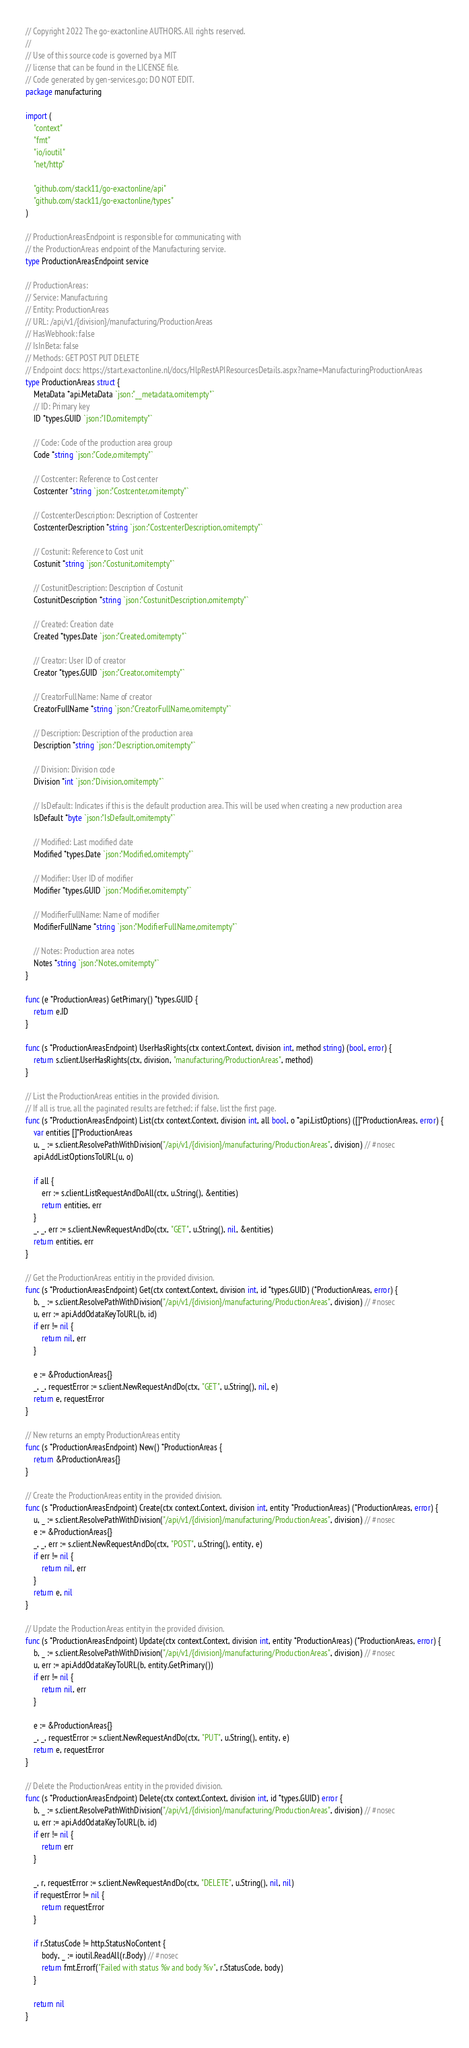<code> <loc_0><loc_0><loc_500><loc_500><_Go_>// Copyright 2022 The go-exactonline AUTHORS. All rights reserved.
//
// Use of this source code is governed by a MIT
// license that can be found in the LICENSE file.
// Code generated by gen-services.go; DO NOT EDIT.
package manufacturing

import (
	"context"
	"fmt"
	"io/ioutil"
	"net/http"

	"github.com/stack11/go-exactonline/api"
	"github.com/stack11/go-exactonline/types"
)

// ProductionAreasEndpoint is responsible for communicating with
// the ProductionAreas endpoint of the Manufacturing service.
type ProductionAreasEndpoint service

// ProductionAreas:
// Service: Manufacturing
// Entity: ProductionAreas
// URL: /api/v1/{division}/manufacturing/ProductionAreas
// HasWebhook: false
// IsInBeta: false
// Methods: GET POST PUT DELETE
// Endpoint docs: https://start.exactonline.nl/docs/HlpRestAPIResourcesDetails.aspx?name=ManufacturingProductionAreas
type ProductionAreas struct {
	MetaData *api.MetaData `json:"__metadata,omitempty"`
	// ID: Primary key
	ID *types.GUID `json:"ID,omitempty"`

	// Code: Code of the production area group
	Code *string `json:"Code,omitempty"`

	// Costcenter: Reference to Cost center
	Costcenter *string `json:"Costcenter,omitempty"`

	// CostcenterDescription: Description of Costcenter
	CostcenterDescription *string `json:"CostcenterDescription,omitempty"`

	// Costunit: Reference to Cost unit
	Costunit *string `json:"Costunit,omitempty"`

	// CostunitDescription: Description of Costunit
	CostunitDescription *string `json:"CostunitDescription,omitempty"`

	// Created: Creation date
	Created *types.Date `json:"Created,omitempty"`

	// Creator: User ID of creator
	Creator *types.GUID `json:"Creator,omitempty"`

	// CreatorFullName: Name of creator
	CreatorFullName *string `json:"CreatorFullName,omitempty"`

	// Description: Description of the production area
	Description *string `json:"Description,omitempty"`

	// Division: Division code
	Division *int `json:"Division,omitempty"`

	// IsDefault: Indicates if this is the default production area. This will be used when creating a new production area
	IsDefault *byte `json:"IsDefault,omitempty"`

	// Modified: Last modified date
	Modified *types.Date `json:"Modified,omitempty"`

	// Modifier: User ID of modifier
	Modifier *types.GUID `json:"Modifier,omitempty"`

	// ModifierFullName: Name of modifier
	ModifierFullName *string `json:"ModifierFullName,omitempty"`

	// Notes: Production area notes
	Notes *string `json:"Notes,omitempty"`
}

func (e *ProductionAreas) GetPrimary() *types.GUID {
	return e.ID
}

func (s *ProductionAreasEndpoint) UserHasRights(ctx context.Context, division int, method string) (bool, error) {
	return s.client.UserHasRights(ctx, division, "manufacturing/ProductionAreas", method)
}

// List the ProductionAreas entities in the provided division.
// If all is true, all the paginated results are fetched; if false, list the first page.
func (s *ProductionAreasEndpoint) List(ctx context.Context, division int, all bool, o *api.ListOptions) ([]*ProductionAreas, error) {
	var entities []*ProductionAreas
	u, _ := s.client.ResolvePathWithDivision("/api/v1/{division}/manufacturing/ProductionAreas", division) // #nosec
	api.AddListOptionsToURL(u, o)

	if all {
		err := s.client.ListRequestAndDoAll(ctx, u.String(), &entities)
		return entities, err
	}
	_, _, err := s.client.NewRequestAndDo(ctx, "GET", u.String(), nil, &entities)
	return entities, err
}

// Get the ProductionAreas entitiy in the provided division.
func (s *ProductionAreasEndpoint) Get(ctx context.Context, division int, id *types.GUID) (*ProductionAreas, error) {
	b, _ := s.client.ResolvePathWithDivision("/api/v1/{division}/manufacturing/ProductionAreas", division) // #nosec
	u, err := api.AddOdataKeyToURL(b, id)
	if err != nil {
		return nil, err
	}

	e := &ProductionAreas{}
	_, _, requestError := s.client.NewRequestAndDo(ctx, "GET", u.String(), nil, e)
	return e, requestError
}

// New returns an empty ProductionAreas entity
func (s *ProductionAreasEndpoint) New() *ProductionAreas {
	return &ProductionAreas{}
}

// Create the ProductionAreas entity in the provided division.
func (s *ProductionAreasEndpoint) Create(ctx context.Context, division int, entity *ProductionAreas) (*ProductionAreas, error) {
	u, _ := s.client.ResolvePathWithDivision("/api/v1/{division}/manufacturing/ProductionAreas", division) // #nosec
	e := &ProductionAreas{}
	_, _, err := s.client.NewRequestAndDo(ctx, "POST", u.String(), entity, e)
	if err != nil {
		return nil, err
	}
	return e, nil
}

// Update the ProductionAreas entity in the provided division.
func (s *ProductionAreasEndpoint) Update(ctx context.Context, division int, entity *ProductionAreas) (*ProductionAreas, error) {
	b, _ := s.client.ResolvePathWithDivision("/api/v1/{division}/manufacturing/ProductionAreas", division) // #nosec
	u, err := api.AddOdataKeyToURL(b, entity.GetPrimary())
	if err != nil {
		return nil, err
	}

	e := &ProductionAreas{}
	_, _, requestError := s.client.NewRequestAndDo(ctx, "PUT", u.String(), entity, e)
	return e, requestError
}

// Delete the ProductionAreas entity in the provided division.
func (s *ProductionAreasEndpoint) Delete(ctx context.Context, division int, id *types.GUID) error {
	b, _ := s.client.ResolvePathWithDivision("/api/v1/{division}/manufacturing/ProductionAreas", division) // #nosec
	u, err := api.AddOdataKeyToURL(b, id)
	if err != nil {
		return err
	}

	_, r, requestError := s.client.NewRequestAndDo(ctx, "DELETE", u.String(), nil, nil)
	if requestError != nil {
		return requestError
	}

	if r.StatusCode != http.StatusNoContent {
		body, _ := ioutil.ReadAll(r.Body) // #nosec
		return fmt.Errorf("Failed with status %v and body %v", r.StatusCode, body)
	}

	return nil
}
</code> 